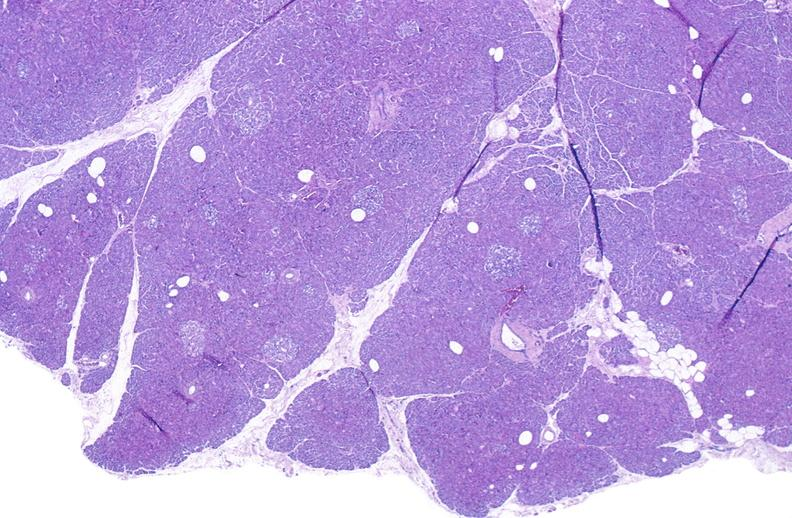does traumatic rupture show normal pancreas?
Answer the question using a single word or phrase. No 